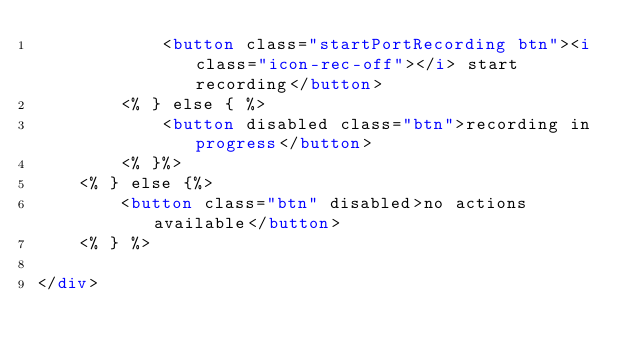Convert code to text. <code><loc_0><loc_0><loc_500><loc_500><_HTML_>            <button class="startPortRecording btn"><i class="icon-rec-off"></i> start recording</button>
        <% } else { %>
            <button disabled class="btn">recording in progress</button>
        <% }%>
    <% } else {%>
        <button class="btn" disabled>no actions available</button>
    <% } %>
    
</div></code> 